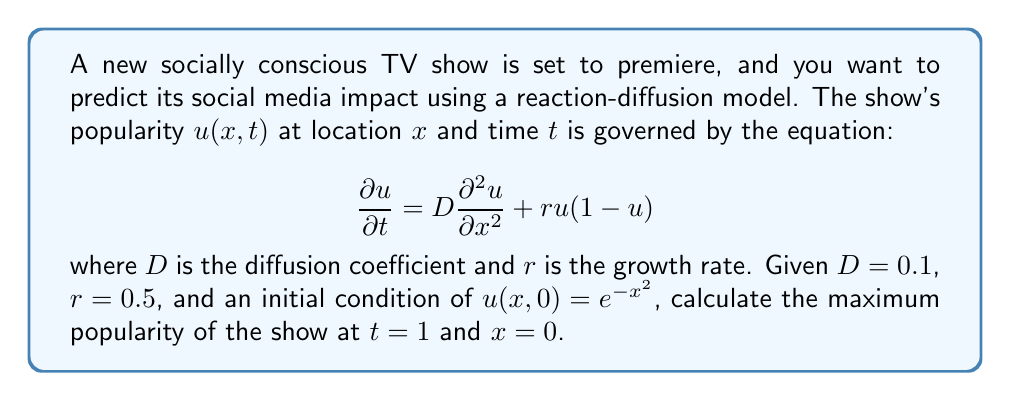Teach me how to tackle this problem. To solve this problem, we need to use the Fisher-KPP equation, which is a type of reaction-diffusion equation. The given equation describes how the popularity of the show spreads (diffusion) and grows (reaction) over time and space.

1. First, we need to find the analytical solution for this equation. The exact solution is complex, but we can use an approximation method called the Cole-Hopf transformation.

2. Let $u(x,t) = \frac{1}{1 + e^{\eta(x,t)}}$, where $\eta(x,t)$ satisfies the heat equation:

   $$\frac{\partial \eta}{\partial t} = D\frac{\partial^2 \eta}{\partial x^2} - r\eta$$

3. The solution to this heat equation with the given initial condition is:

   $$\eta(x,t) = \frac{x^2 + Drt}{4Dt + 1}$$

4. Substituting this back into the Cole-Hopf transformation:

   $$u(x,t) = \frac{1}{1 + e^{\frac{x^2 + Drt}{4Dt + 1}}}$$

5. Now, we need to evaluate this at $t=1$ and $x=0$:

   $$u(0,1) = \frac{1}{1 + e^{\frac{Dr}{4D + 1}}}$$

6. Substituting the given values $D=0.1$ and $r=0.5$:

   $$u(0,1) = \frac{1}{1 + e^{\frac{0.1 \cdot 0.5}{4 \cdot 0.1 + 1}}} = \frac{1}{1 + e^{\frac{0.05}{1.4}}}$$

7. Calculating this value:

   $$u(0,1) \approx 0.9651$$

This represents the maximum popularity of the show at $t=1$ and $x=0$, where 1 would indicate complete saturation of the market.
Answer: The maximum popularity of the show at $t=1$ and $x=0$ is approximately 0.9651 or 96.51%. 